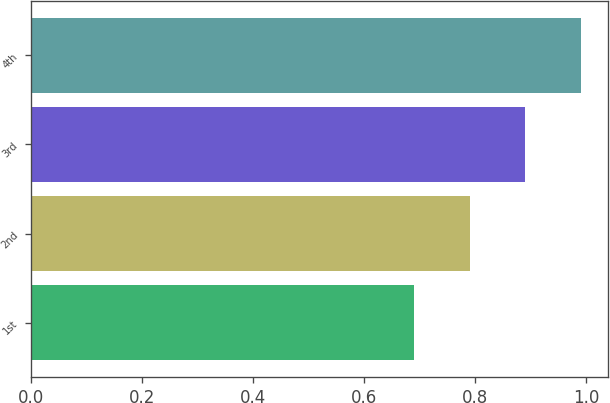Convert chart to OTSL. <chart><loc_0><loc_0><loc_500><loc_500><bar_chart><fcel>1st<fcel>2nd<fcel>3rd<fcel>4th<nl><fcel>0.69<fcel>0.79<fcel>0.89<fcel>0.99<nl></chart> 